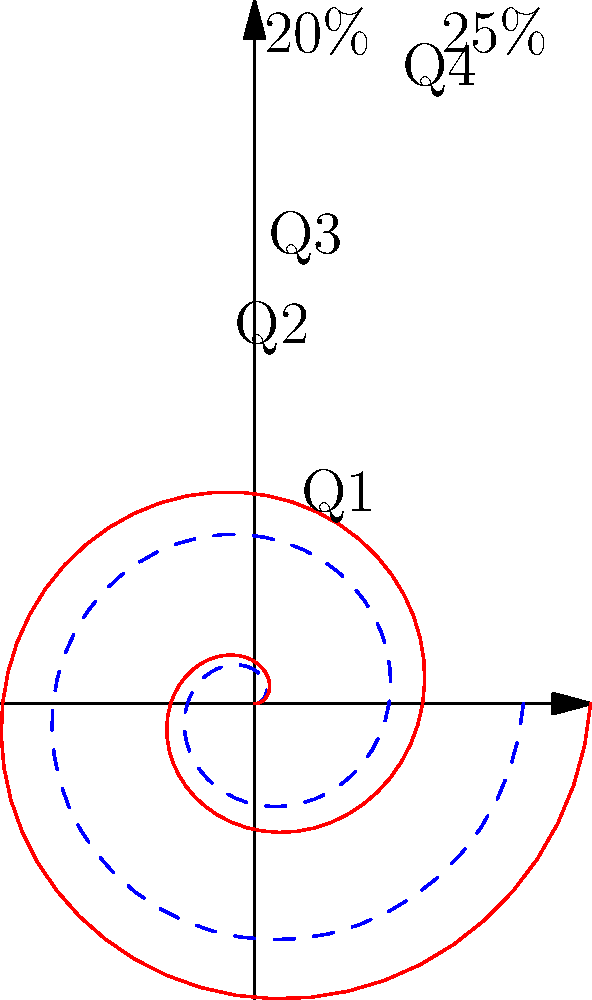As the general manager, you're reviewing a spiral plot representing cumulative sales performance over a year. The blue dashed line shows the target, while the red solid line represents actual performance. By the end of Q4, how much has the sales team exceeded or fallen short of the annual target in percentage points? To determine how much the sales team has exceeded or fallen short of the annual target, we need to follow these steps:

1. Identify the target and actual performance at the end of Q4 (full rotation):
   - The blue dashed line (target) completes one rotation at 20% (0.2 * 2π)
   - The red solid line (actual) completes one rotation at 25% (0.25 * 2π)

2. Calculate the difference between actual and target performance:
   $25\% - 20\% = 5\%$

3. Interpret the result:
   The positive difference indicates that the sales team has exceeded the target.

Therefore, by the end of Q4, the sales team has exceeded the annual target by 5 percentage points.
Answer: Exceeded by 5 percentage points 